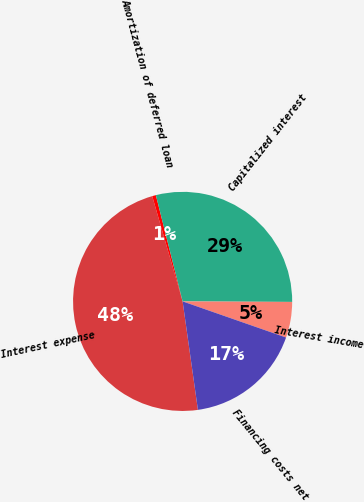Convert chart. <chart><loc_0><loc_0><loc_500><loc_500><pie_chart><fcel>Interest expense<fcel>Amortization of deferred loan<fcel>Capitalized interest<fcel>Interest income<fcel>Financing costs net<nl><fcel>47.75%<fcel>0.55%<fcel>29.0%<fcel>5.27%<fcel>17.42%<nl></chart> 